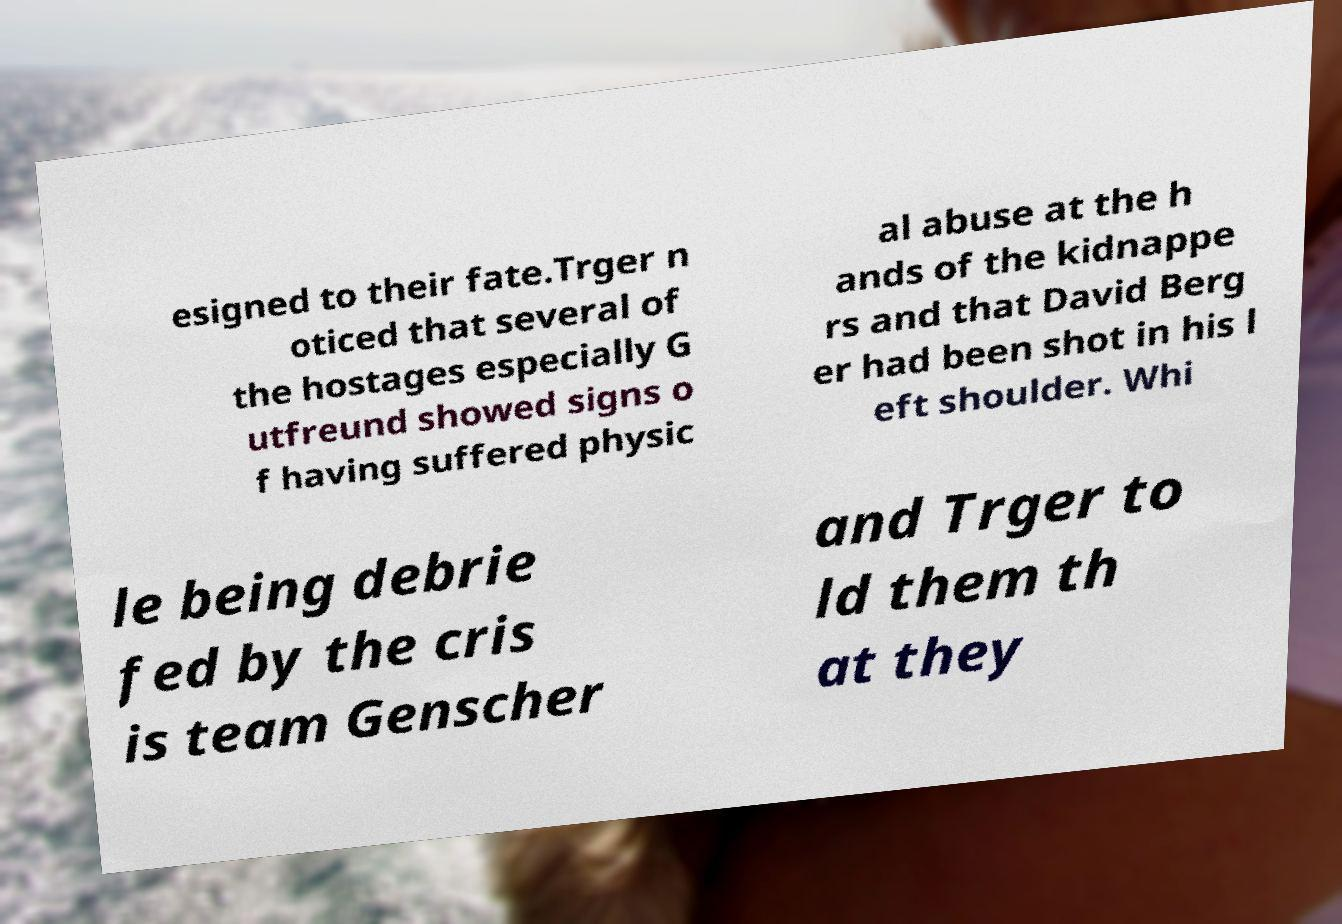Could you extract and type out the text from this image? esigned to their fate.Trger n oticed that several of the hostages especially G utfreund showed signs o f having suffered physic al abuse at the h ands of the kidnappe rs and that David Berg er had been shot in his l eft shoulder. Whi le being debrie fed by the cris is team Genscher and Trger to ld them th at they 